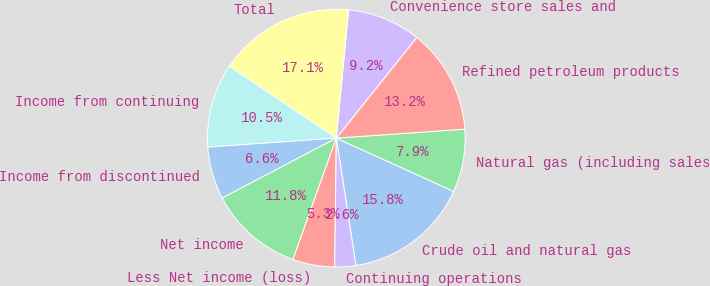Convert chart to OTSL. <chart><loc_0><loc_0><loc_500><loc_500><pie_chart><fcel>Crude oil and natural gas<fcel>Natural gas (including sales<fcel>Refined petroleum products<fcel>Convenience store sales and<fcel>Total<fcel>Income from continuing<fcel>Income from discontinued<fcel>Net income<fcel>Less Net income (loss)<fcel>Continuing operations<nl><fcel>15.79%<fcel>7.89%<fcel>13.16%<fcel>9.21%<fcel>17.11%<fcel>10.53%<fcel>6.58%<fcel>11.84%<fcel>5.26%<fcel>2.63%<nl></chart> 